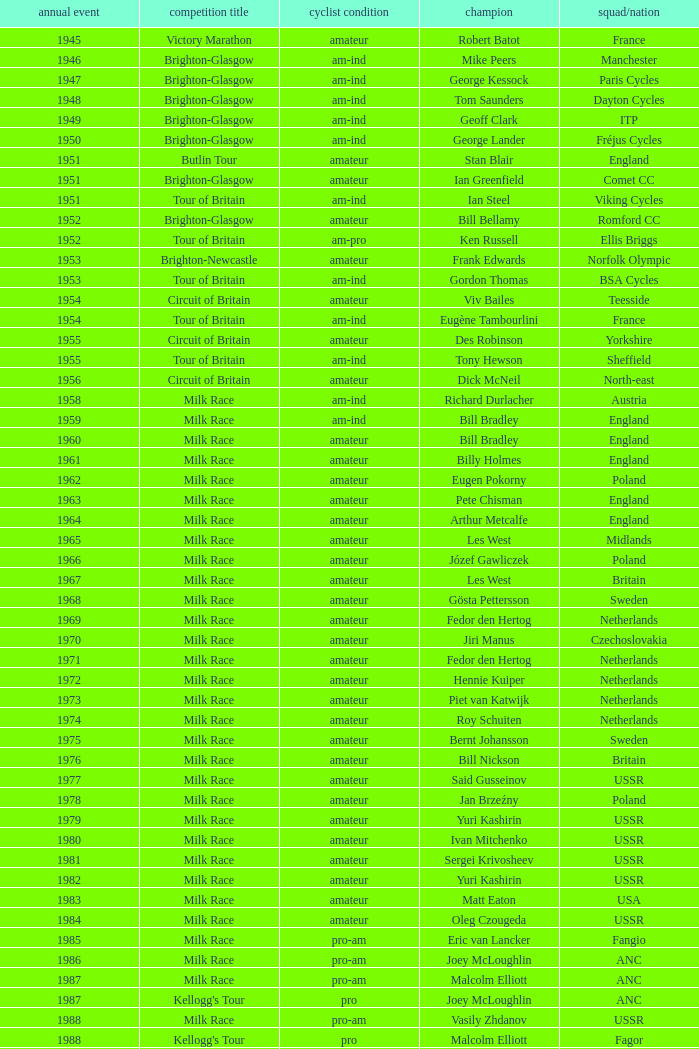What is the latest year when Phil Anderson won? 1993.0. 